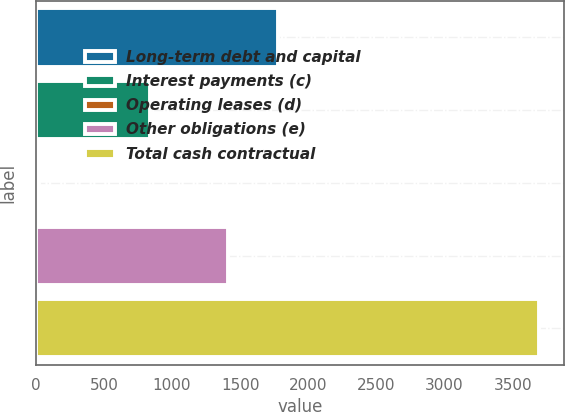Convert chart to OTSL. <chart><loc_0><loc_0><loc_500><loc_500><bar_chart><fcel>Long-term debt and capital<fcel>Interest payments (c)<fcel>Operating leases (d)<fcel>Other obligations (e)<fcel>Total cash contractual<nl><fcel>1775<fcel>841<fcel>24<fcel>1408<fcel>3694<nl></chart> 